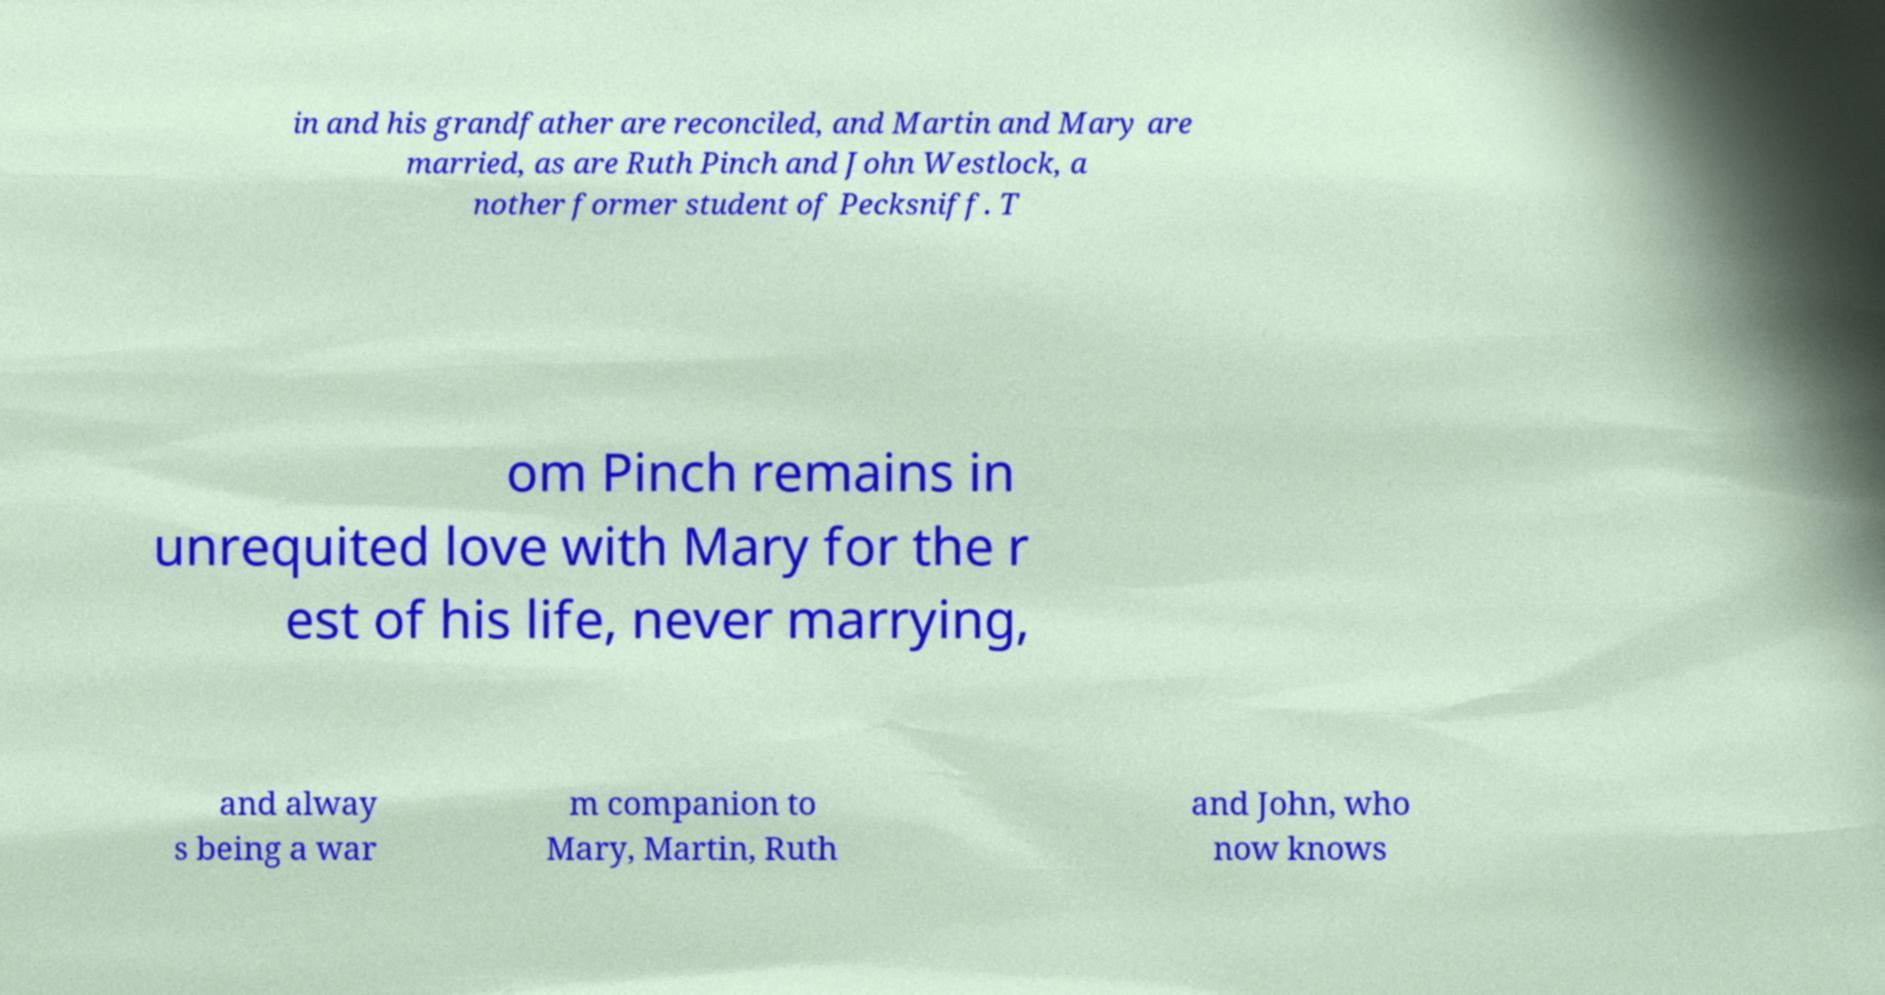What messages or text are displayed in this image? I need them in a readable, typed format. in and his grandfather are reconciled, and Martin and Mary are married, as are Ruth Pinch and John Westlock, a nother former student of Pecksniff. T om Pinch remains in unrequited love with Mary for the r est of his life, never marrying, and alway s being a war m companion to Mary, Martin, Ruth and John, who now knows 